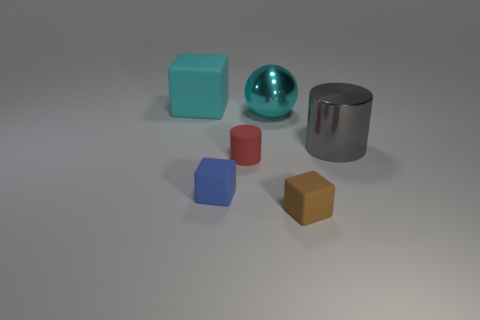Add 2 large purple metal cylinders. How many objects exist? 8 Subtract all small cubes. How many cubes are left? 1 Subtract all spheres. How many objects are left? 5 Subtract 3 blocks. How many blocks are left? 0 Subtract all red spheres. Subtract all blue cylinders. How many spheres are left? 1 Subtract all cyan cubes. How many yellow cylinders are left? 0 Subtract all small brown things. Subtract all blue shiny blocks. How many objects are left? 5 Add 5 cyan things. How many cyan things are left? 7 Add 1 gray matte objects. How many gray matte objects exist? 1 Subtract all red cylinders. How many cylinders are left? 1 